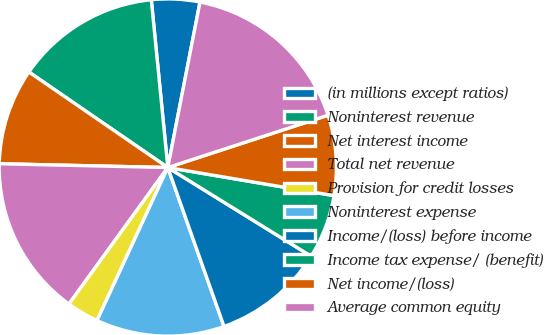Convert chart. <chart><loc_0><loc_0><loc_500><loc_500><pie_chart><fcel>(in millions except ratios)<fcel>Noninterest revenue<fcel>Net interest income<fcel>Total net revenue<fcel>Provision for credit losses<fcel>Noninterest expense<fcel>Income/(loss) before income<fcel>Income tax expense/ (benefit)<fcel>Net income/(loss)<fcel>Average common equity<nl><fcel>4.62%<fcel>13.85%<fcel>9.23%<fcel>15.38%<fcel>3.08%<fcel>12.31%<fcel>10.77%<fcel>6.15%<fcel>7.69%<fcel>16.92%<nl></chart> 